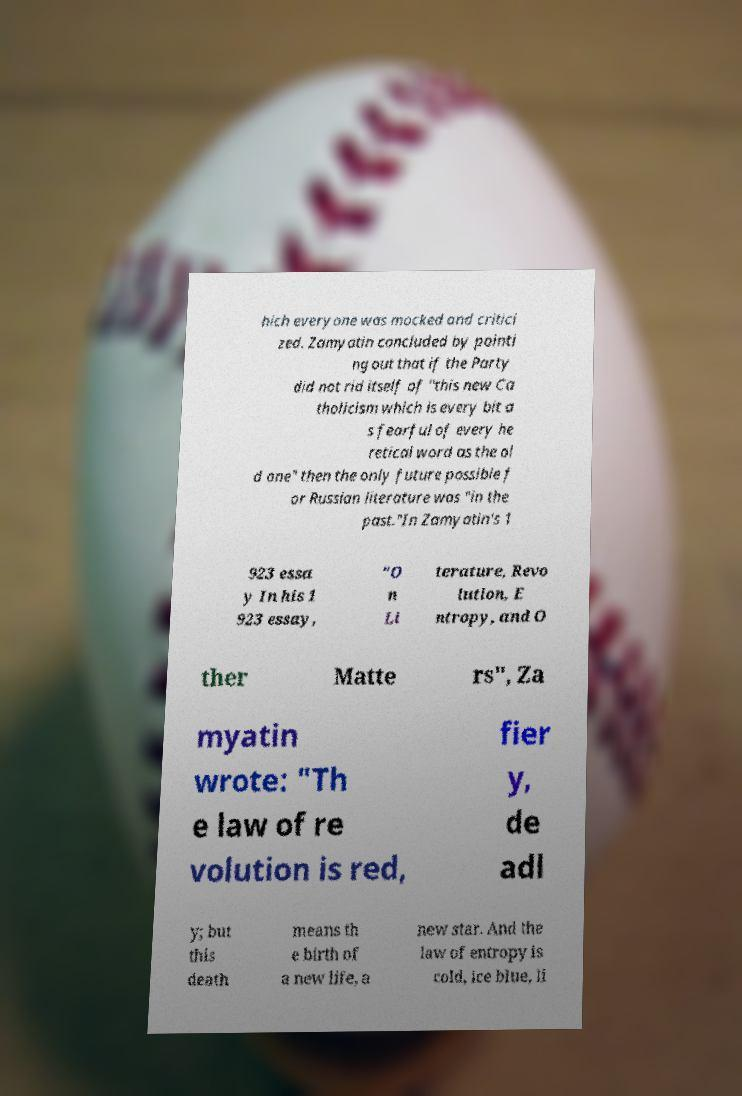There's text embedded in this image that I need extracted. Can you transcribe it verbatim? hich everyone was mocked and critici zed. Zamyatin concluded by pointi ng out that if the Party did not rid itself of "this new Ca tholicism which is every bit a s fearful of every he retical word as the ol d one" then the only future possible f or Russian literature was "in the past."In Zamyatin's 1 923 essa y In his 1 923 essay, "O n Li terature, Revo lution, E ntropy, and O ther Matte rs", Za myatin wrote: "Th e law of re volution is red, fier y, de adl y; but this death means th e birth of a new life, a new star. And the law of entropy is cold, ice blue, li 